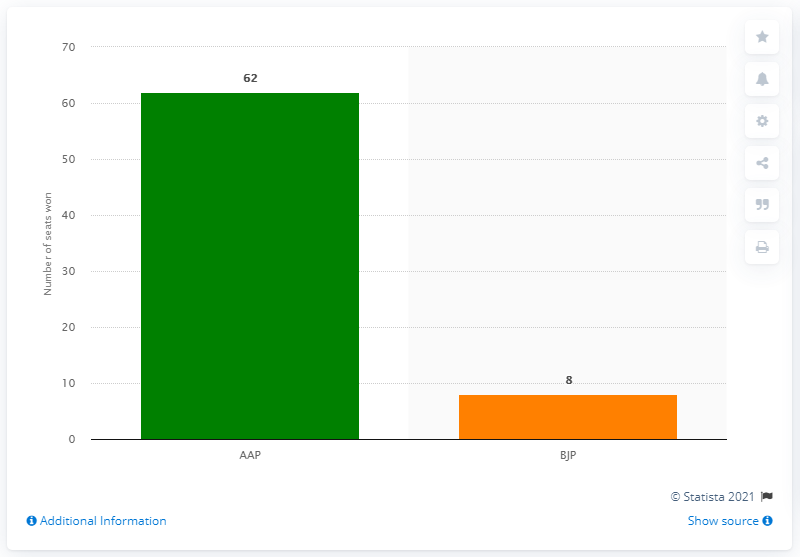Draw attention to some important aspects in this diagram. The AAP is predicted to win more seats in the upcoming election. The ratio of seats held by the two major political parties is approximately 7.75. 